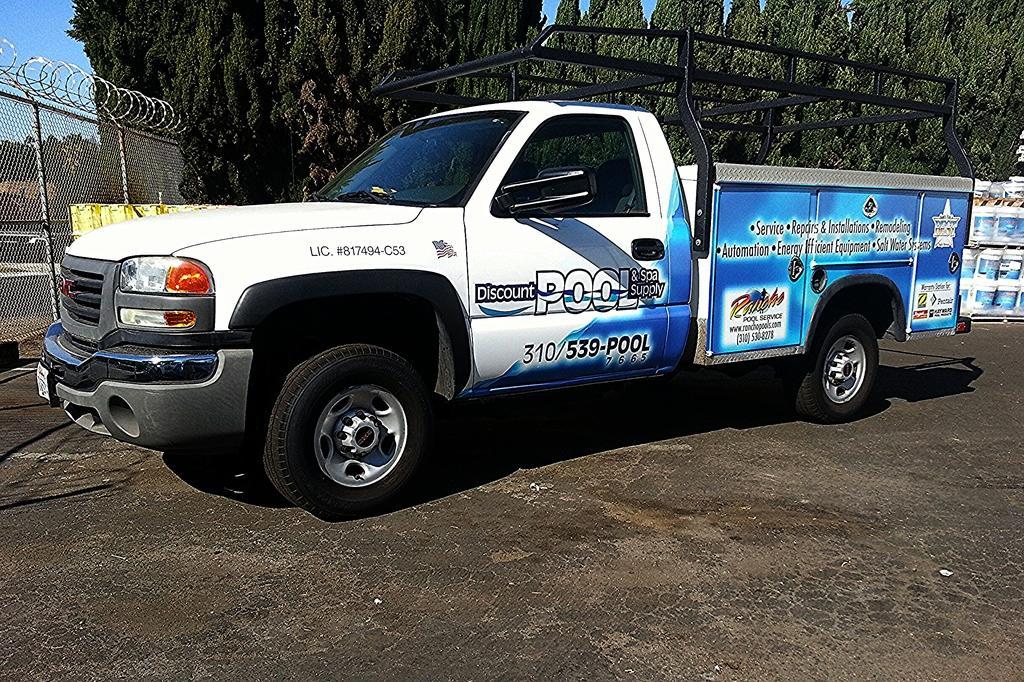Please provide a concise description of this image. Here I can see a truck on the road which is facing towards the left side. In the background there are some trees and few buckets. On the left side, I can see a net fencing. On the left top of the image I can see the sky. 